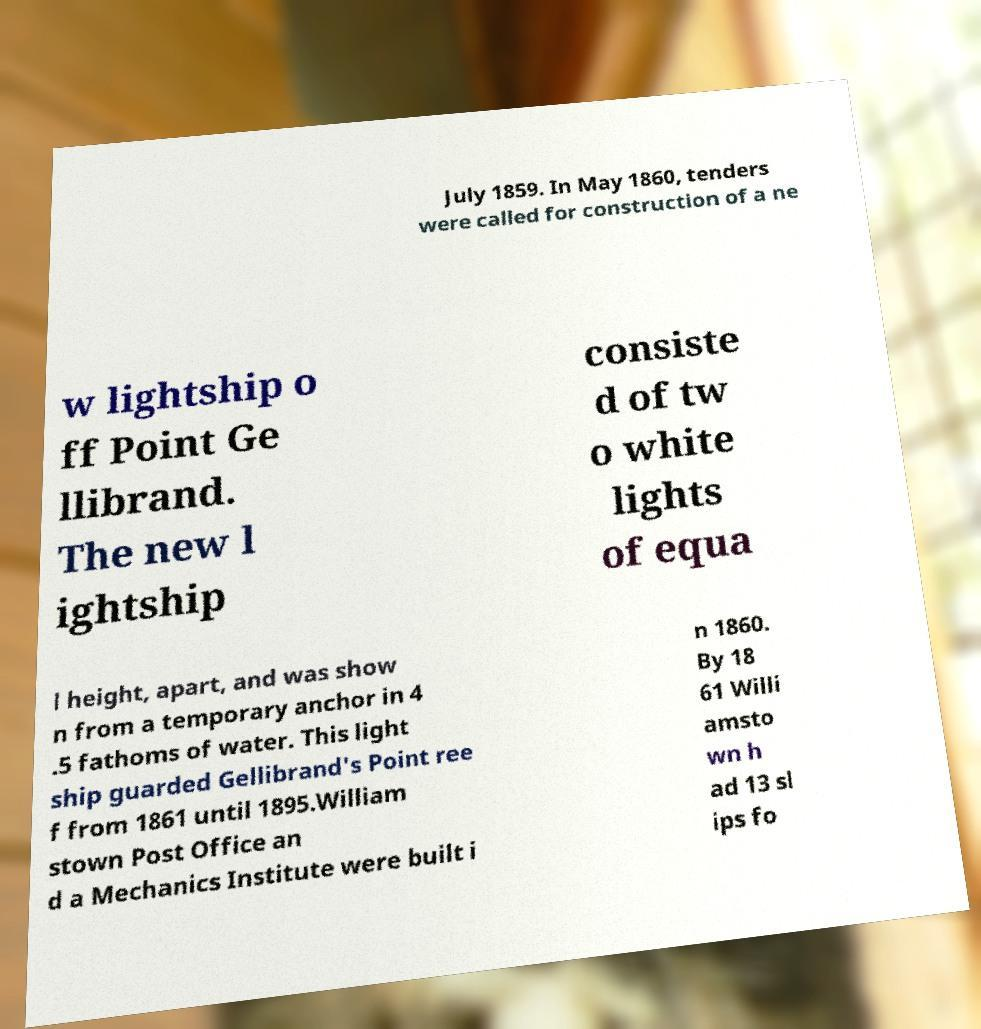Please identify and transcribe the text found in this image. July 1859. In May 1860, tenders were called for construction of a ne w lightship o ff Point Ge llibrand. The new l ightship consiste d of tw o white lights of equa l height, apart, and was show n from a temporary anchor in 4 .5 fathoms of water. This light ship guarded Gellibrand's Point ree f from 1861 until 1895.William stown Post Office an d a Mechanics Institute were built i n 1860. By 18 61 Willi amsto wn h ad 13 sl ips fo 